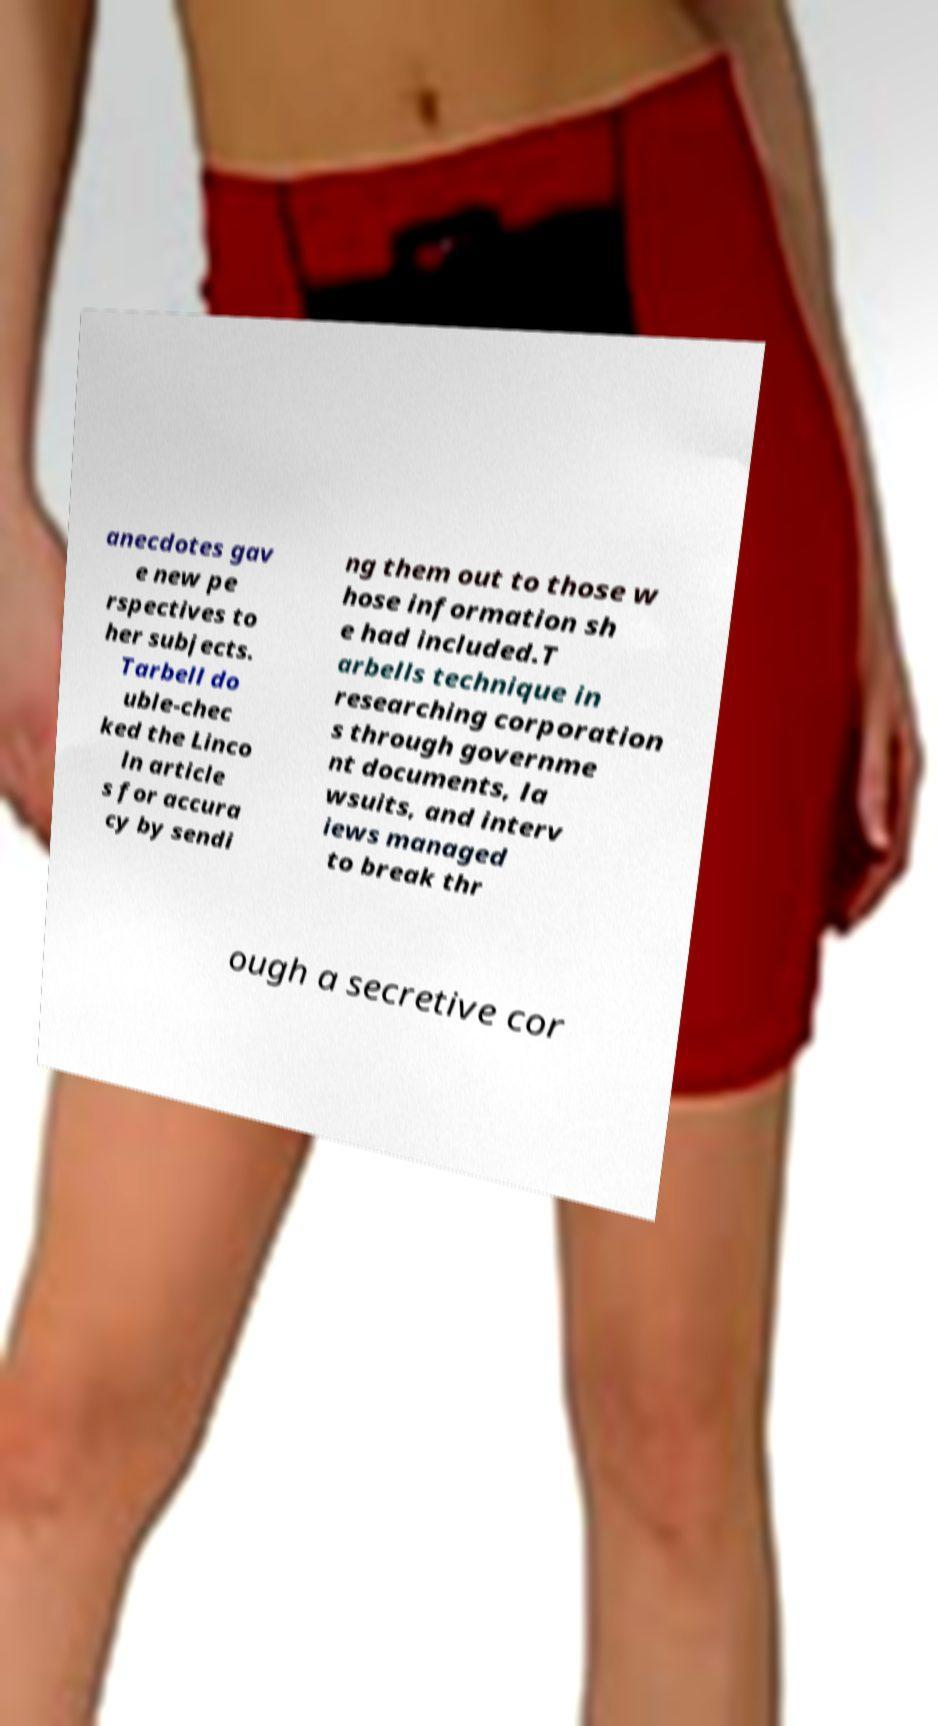Can you read and provide the text displayed in the image?This photo seems to have some interesting text. Can you extract and type it out for me? anecdotes gav e new pe rspectives to her subjects. Tarbell do uble-chec ked the Linco ln article s for accura cy by sendi ng them out to those w hose information sh e had included.T arbells technique in researching corporation s through governme nt documents, la wsuits, and interv iews managed to break thr ough a secretive cor 